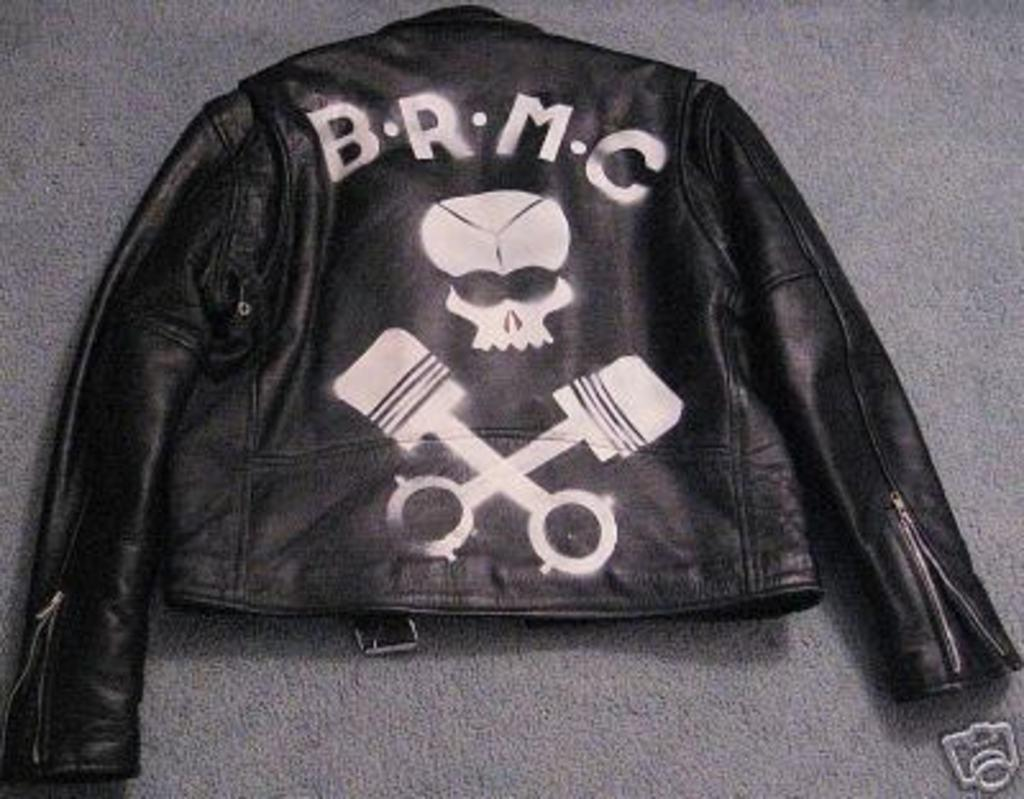What type of clothing item is featured in the image? There is a black color jacket in the image. What is unique about the jacket? The jacket has writing and drawing on it. What type of pipe is visible in the image? There is no pipe present in the image; it features a black color jacket with writing and drawing on it. 